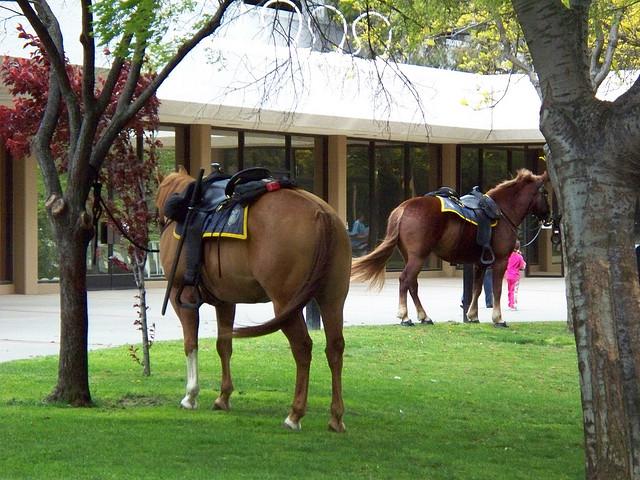What kind of saddles do the horses have?
Concise answer only. Leather. How many trees are in the grass?
Write a very short answer. 3. What kind of animal is this?
Answer briefly. Horse. 